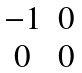<formula> <loc_0><loc_0><loc_500><loc_500>\begin{matrix} - 1 & 0 \\ 0 & 0 \end{matrix}</formula> 